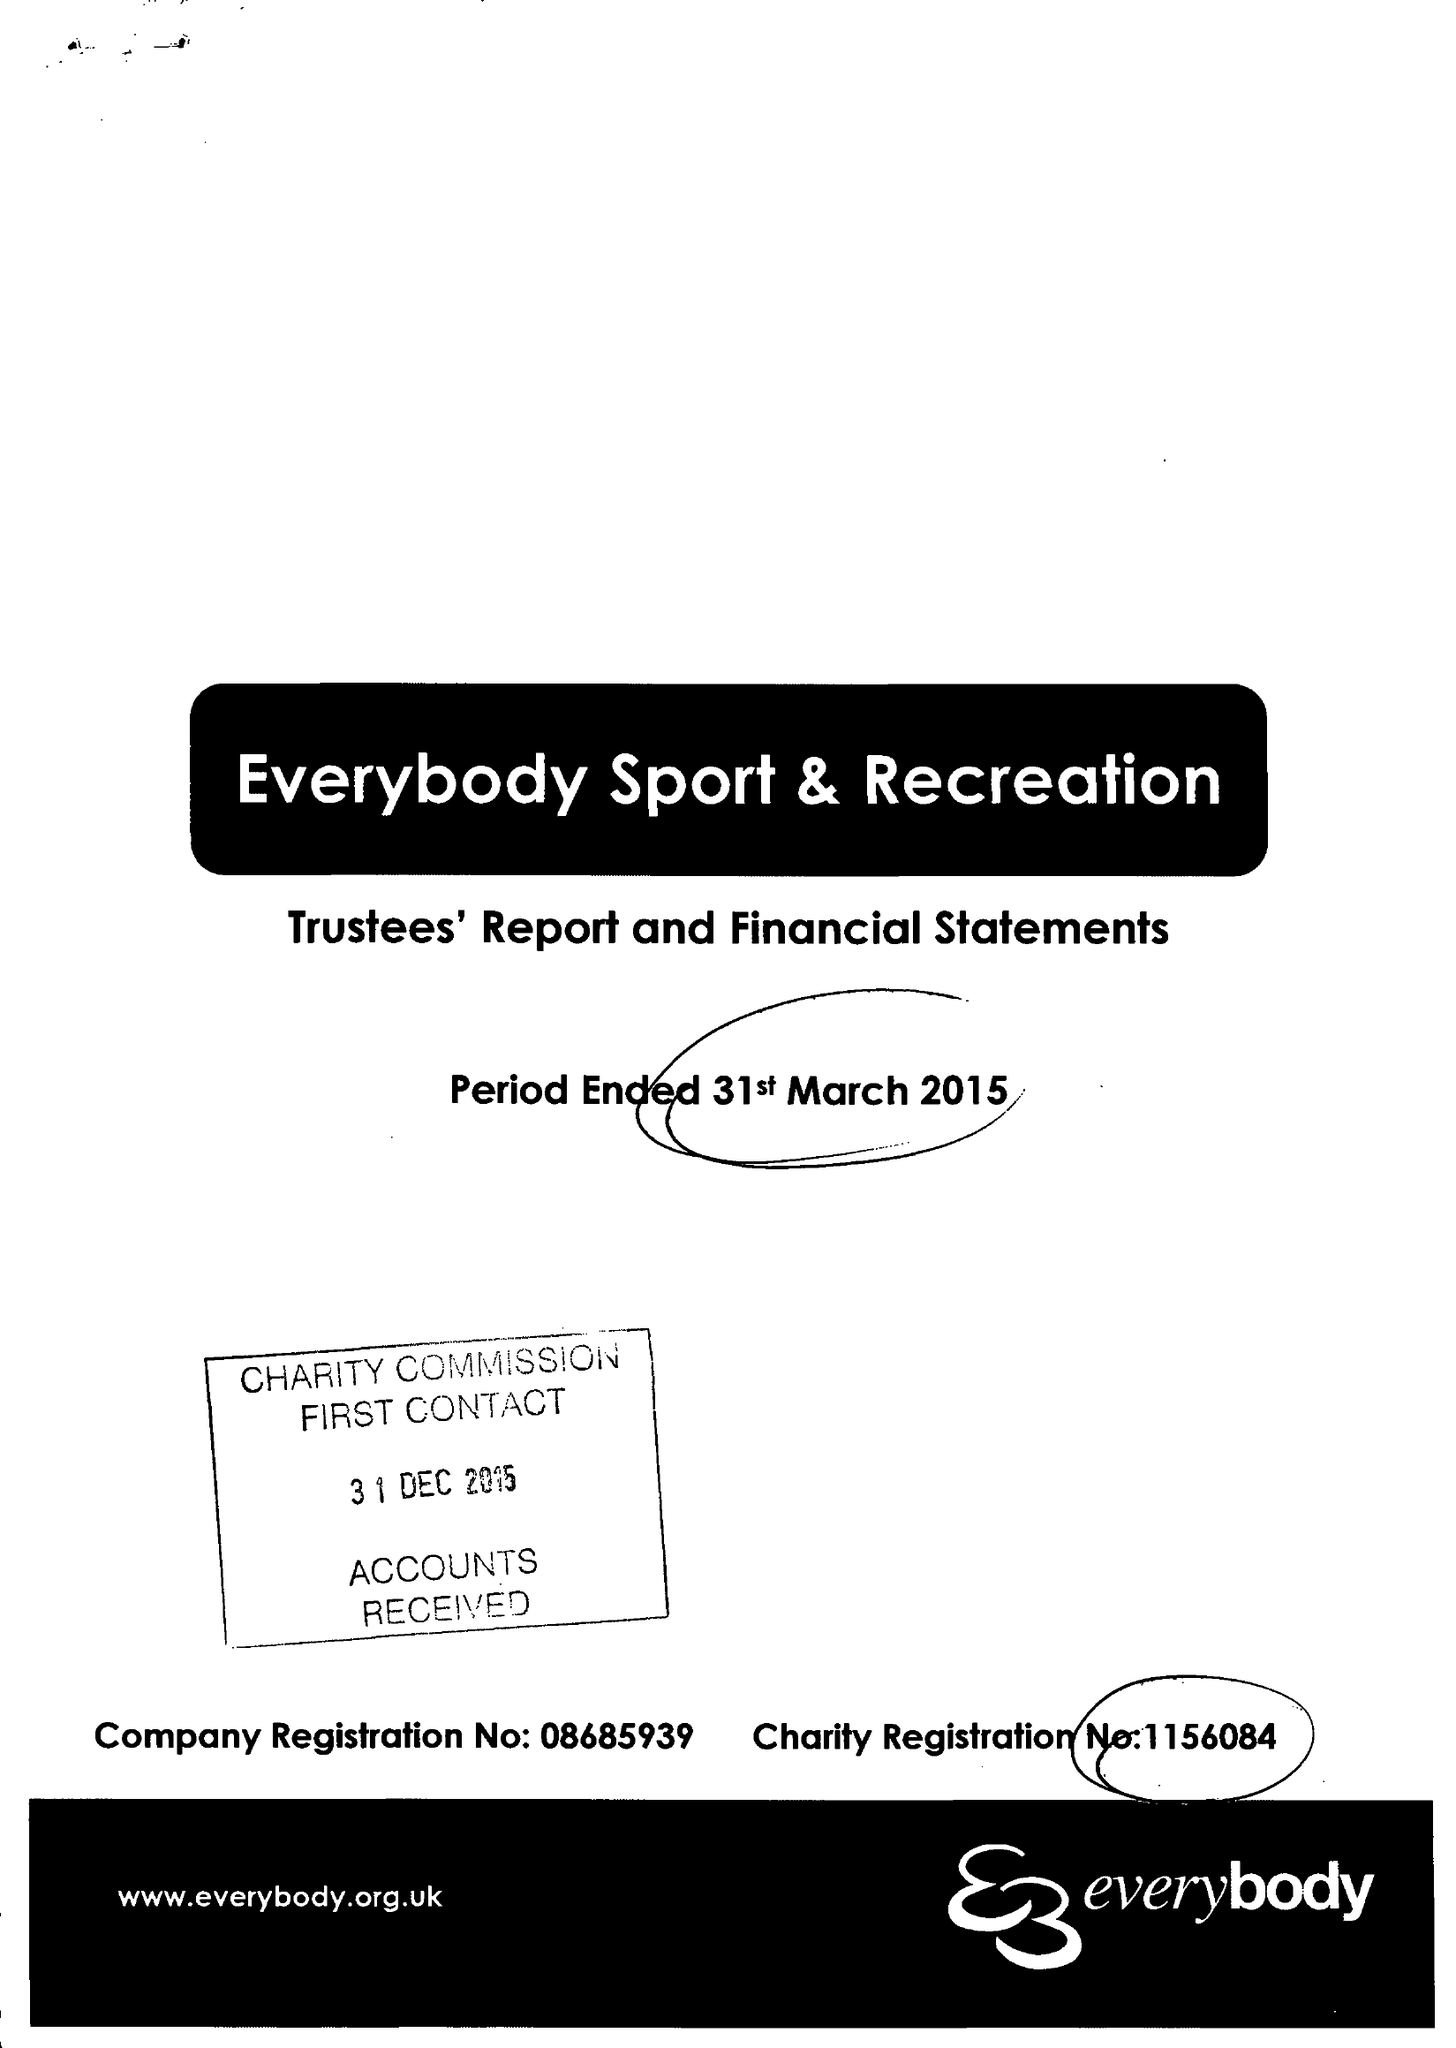What is the value for the address__postcode?
Answer the question using a single word or phrase. CW4 8AA 